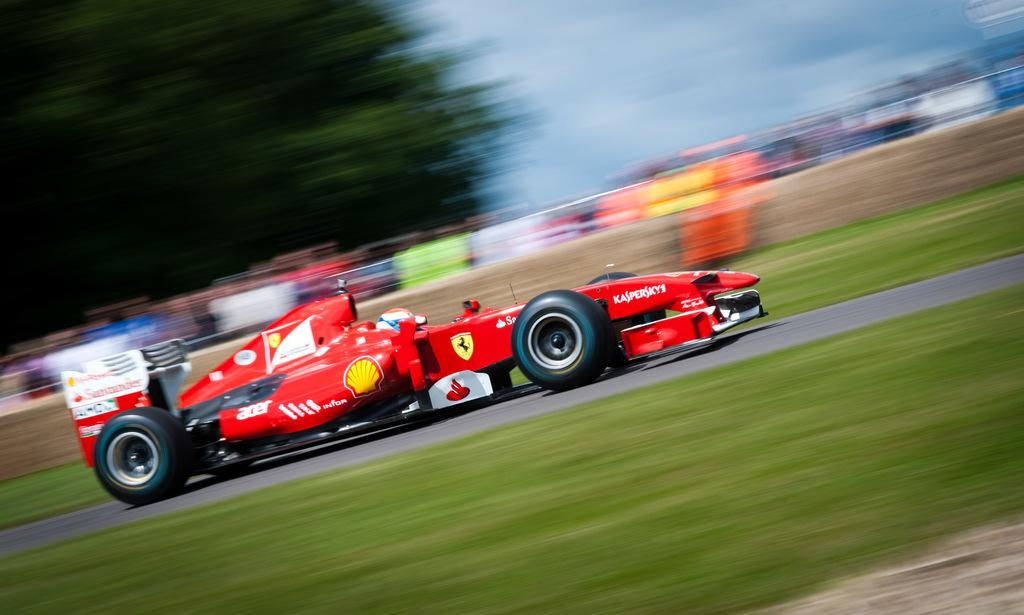What is the person in the image doing? There is a person riding a car in the image. Where is the car located? The car is on the road in the image. What can be seen at the top of the image? The sky is visible at the top of the image, and there are clouds in the sky. What is at the bottom of the image? There is grass at the bottom of the image. What type of surface is the car traveling on? There is a road in the image, and the car is on the road. What color is the sweater the person is wearing while riding the car in the image? There is no information about the person's clothing in the image, so we cannot determine the color of any sweater they might be wearing. 